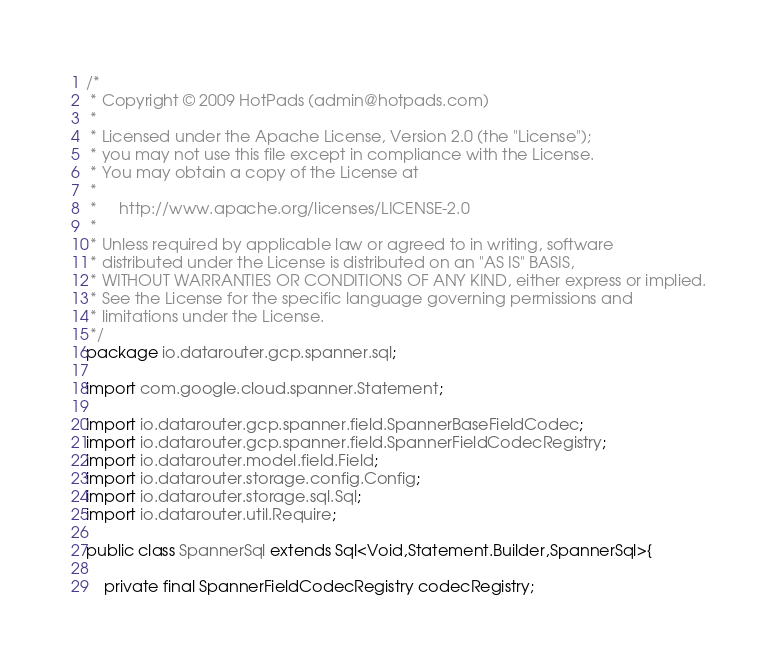<code> <loc_0><loc_0><loc_500><loc_500><_Java_>/*
 * Copyright © 2009 HotPads (admin@hotpads.com)
 *
 * Licensed under the Apache License, Version 2.0 (the "License");
 * you may not use this file except in compliance with the License.
 * You may obtain a copy of the License at
 *
 *     http://www.apache.org/licenses/LICENSE-2.0
 *
 * Unless required by applicable law or agreed to in writing, software
 * distributed under the License is distributed on an "AS IS" BASIS,
 * WITHOUT WARRANTIES OR CONDITIONS OF ANY KIND, either express or implied.
 * See the License for the specific language governing permissions and
 * limitations under the License.
 */
package io.datarouter.gcp.spanner.sql;

import com.google.cloud.spanner.Statement;

import io.datarouter.gcp.spanner.field.SpannerBaseFieldCodec;
import io.datarouter.gcp.spanner.field.SpannerFieldCodecRegistry;
import io.datarouter.model.field.Field;
import io.datarouter.storage.config.Config;
import io.datarouter.storage.sql.Sql;
import io.datarouter.util.Require;

public class SpannerSql extends Sql<Void,Statement.Builder,SpannerSql>{

	private final SpannerFieldCodecRegistry codecRegistry;
</code> 